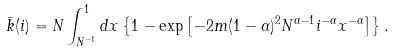Convert formula to latex. <formula><loc_0><loc_0><loc_500><loc_500>\bar { k } ( i ) = N \int _ { N ^ { - 1 } } ^ { 1 } d x \left \{ 1 - \exp \left [ - 2 m ( 1 - \alpha ) ^ { 2 } N ^ { \alpha - 1 } i ^ { - \alpha } x ^ { - \alpha } \right ] \right \} .</formula> 